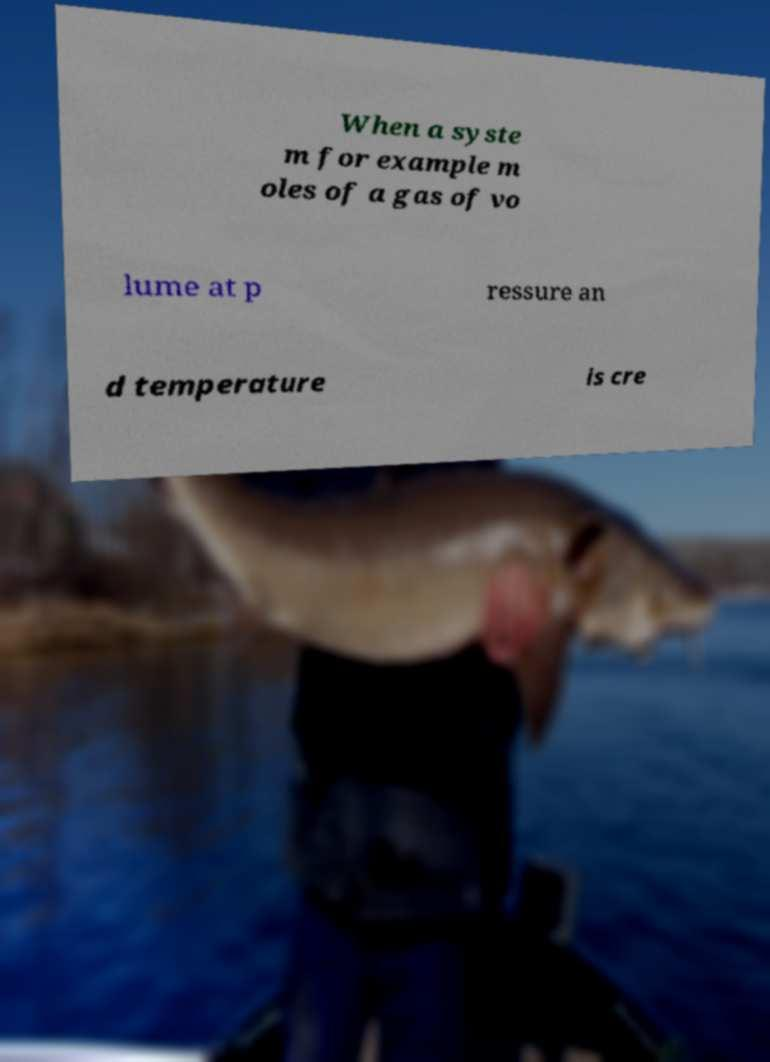Can you accurately transcribe the text from the provided image for me? When a syste m for example m oles of a gas of vo lume at p ressure an d temperature is cre 